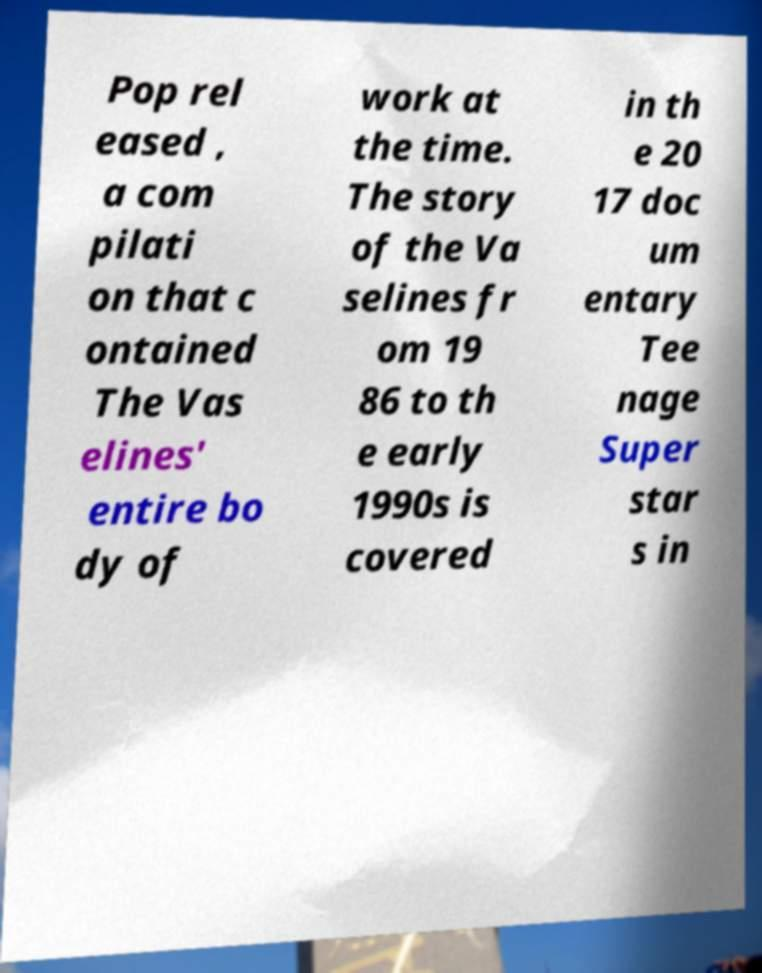What messages or text are displayed in this image? I need them in a readable, typed format. Pop rel eased , a com pilati on that c ontained The Vas elines' entire bo dy of work at the time. The story of the Va selines fr om 19 86 to th e early 1990s is covered in th e 20 17 doc um entary Tee nage Super star s in 